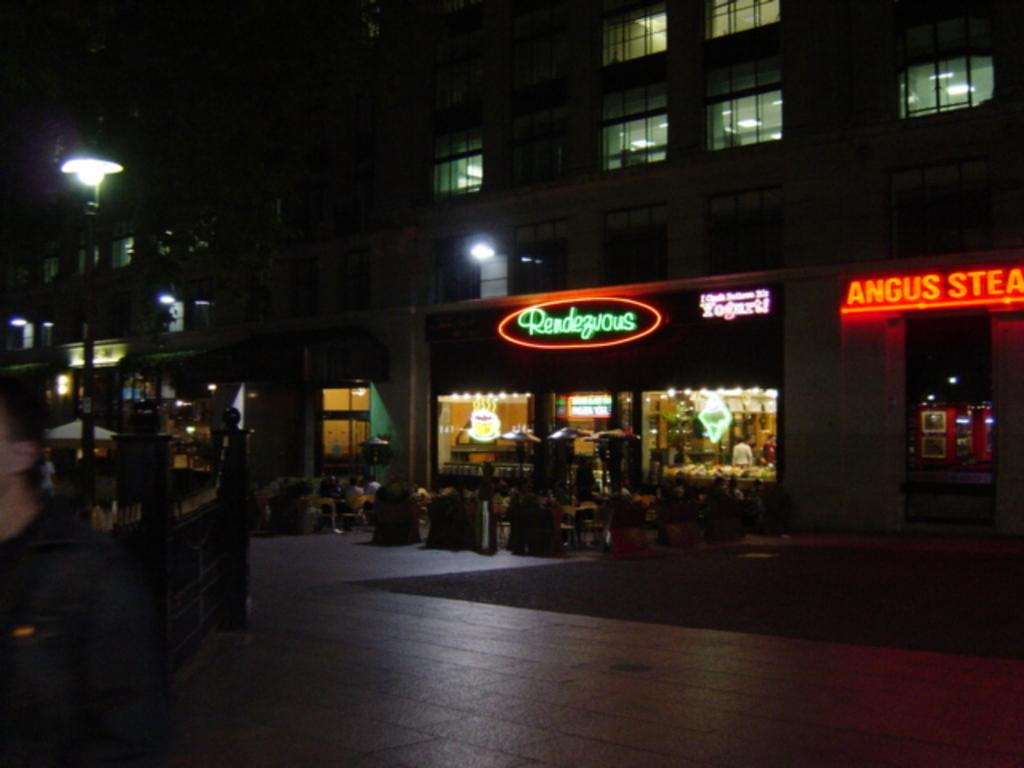How many people are in the image? There is a group of people in the image. What are the people doing in the image? The people are sitting on cars. What else can be seen in the image besides the people and cars? There are plants, light boards, a building, and a pole in the image. What is the purpose of the pole in the image? The pole appears to be an umbrella. What type of scarf is being worn by the person sitting on the car? There is no scarf visible in the image; the people are sitting on cars without any visible accessories. 